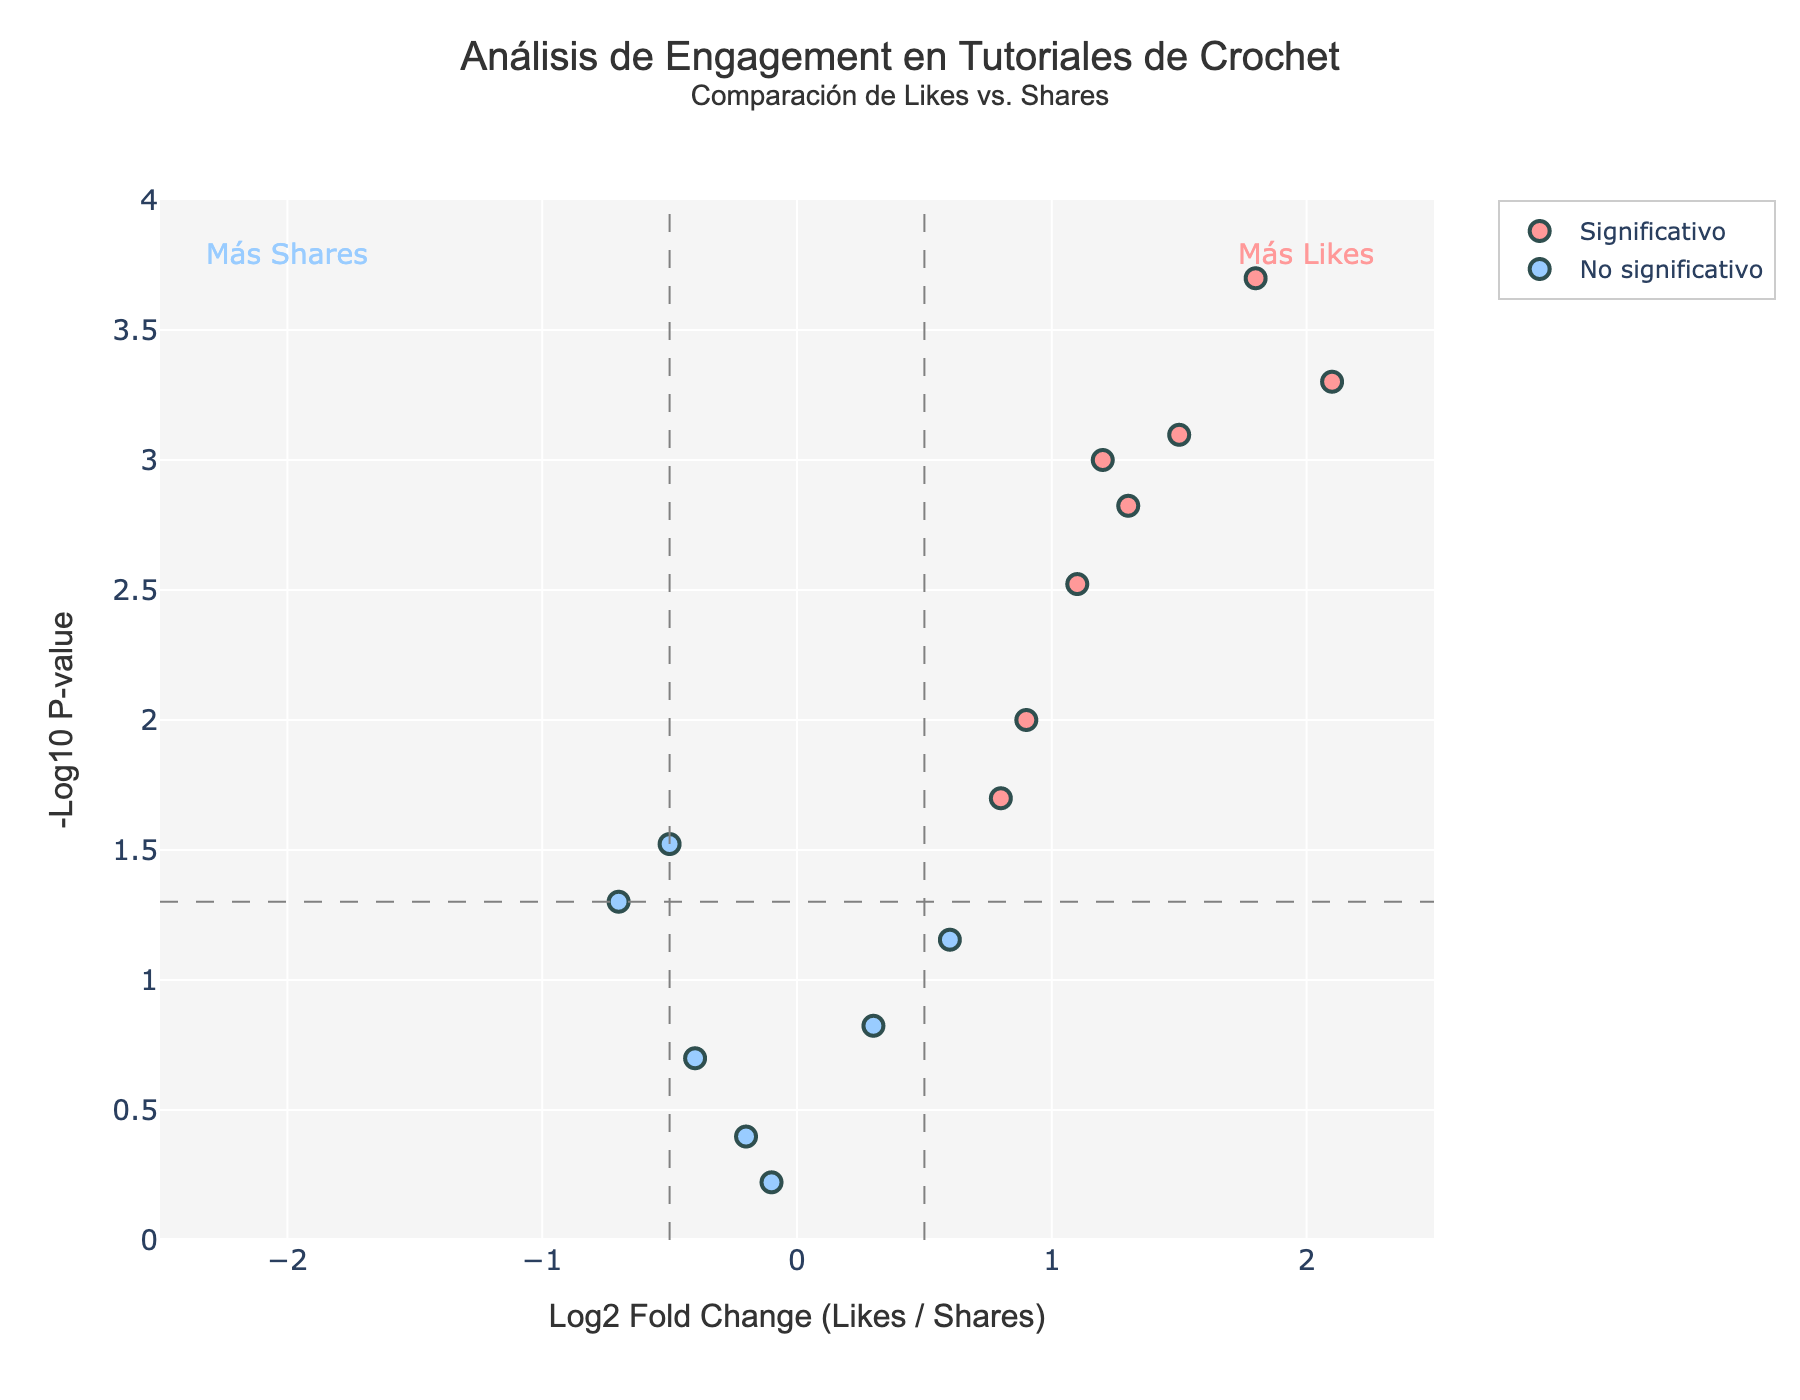What's the title of the plot? The title is typically located at the top of the figure. In this case, the title of the plot is displayed as 'Análisis de Engagement en Tutoriales de Crochet<br><sup>Comparación de Likes vs. Shares</sup>'.
Answer: Análisis de Engagement en Tutoriales de Crochet: Comparación de Likes vs. Shares What do the colors of the points indicate? The figure uses two colors to categorize the data points. According to the code, '#FF9999' represents 'Significativo' (Significant) and '#99CCFF' represents 'No significativo' (Not significant).
Answer: Red indicates 'Significativo' and Blue indicates 'No significativo' What is the significance threshold for the p-value in this Volcano Plot? The significance threshold for the p-value is represented by the horizontal dashed grey line. In the code, this threshold is given by a p-value of 0.05 (or -log10(p-value) ~ 1.301).
Answer: 0.05 How many tutorials are classified as 'Significativo'? The points classified as 'Significativo' are shown in red in the plot. By counting these points, we can determine the total.
Answer: 9 Which tutorial has the highest engagement in terms of Log2 Fold Change? The tutorial with the highest Log2 Fold Change will have the point furthest to the right on the x-axis. From the dataset, 'Magic Ring Technique' has the highest fold change of 2.1.
Answer: Magic Ring Technique Which tutorial exhibits the smallest p-value? The smallest p-value corresponds to the highest point on the y-axis (-log10(p-value)). From the dataset, 'Stuffing Techniques' has the smallest p-value of 0.0002.
Answer: Stuffing Techniques Are there any tutorials with negative Log2 Fold Change that are also considered significant? To answer this, we need to look at tutorials with negative Log2 Fold Changes (left side of the plot) that are colored red, indicating significance. According to the plot, there are no such points.
Answer: No What do the annotations ‘Más Likes’ and ‘Más Shares’ indicate? These annotations explain which side of the plot represents more likes or more shares relative to each other. 'Más Likes' is on the right, signifying a higher ratio of likes to shares, and 'Más Shares' is on the left, indicating a higher ratio of shares to likes.
Answer: 'Más Likes' indicates more likes, 'Más Shares' indicates more shares Is the tutorial 'Yarn Selection' classified as significant or not significant? The tutorial 'Yarn Selection' can be identified by its Log2 Fold Change and p-value. 'Yarn Selection' has a Log2 Fold Change of 0.6 and p-value of 0.07, placing it in the 'No significativo' category.
Answer: No significativo 